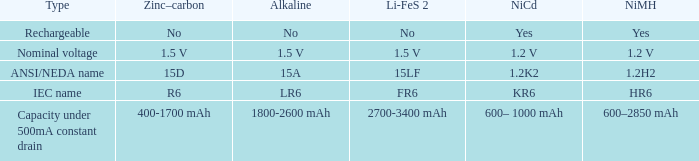What is NiCd, when Type is "Capacity under 500mA constant Drain"? 600– 1000 mAh. 